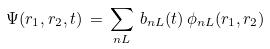<formula> <loc_0><loc_0><loc_500><loc_500>\Psi ( { r } _ { 1 } , { r } _ { 2 } , t ) \, = \, \sum _ { n L } \, b _ { n L } ( t ) \, \phi _ { n L } ( { r } _ { 1 } , { r } _ { 2 } )</formula> 